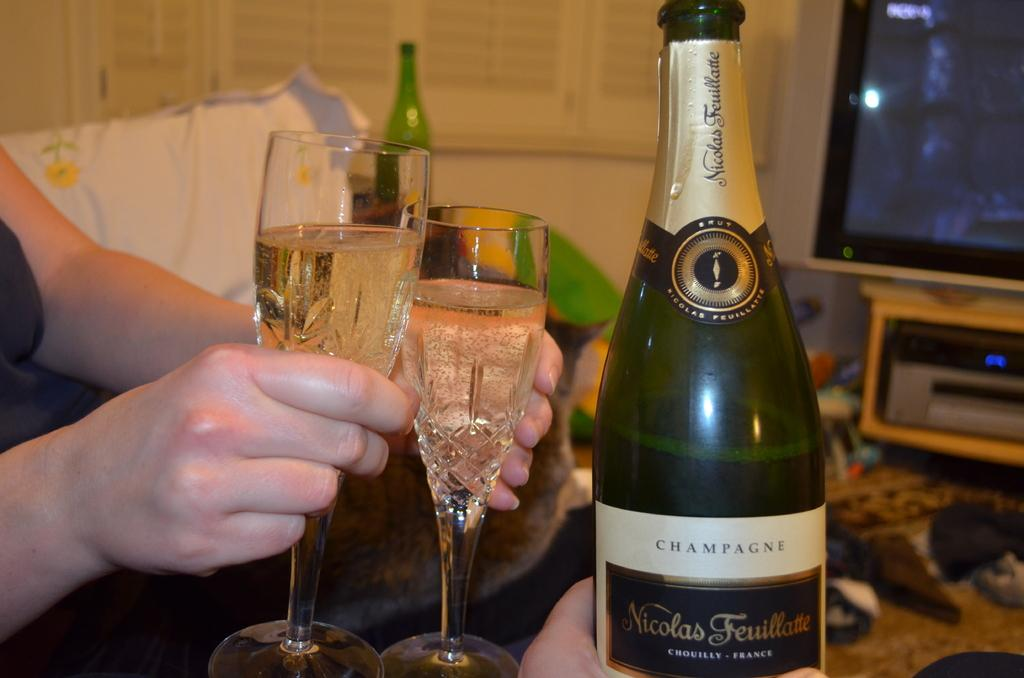<image>
Render a clear and concise summary of the photo. A bottle of CHAMPAGNE with 2 glasses next to it held by a person. 